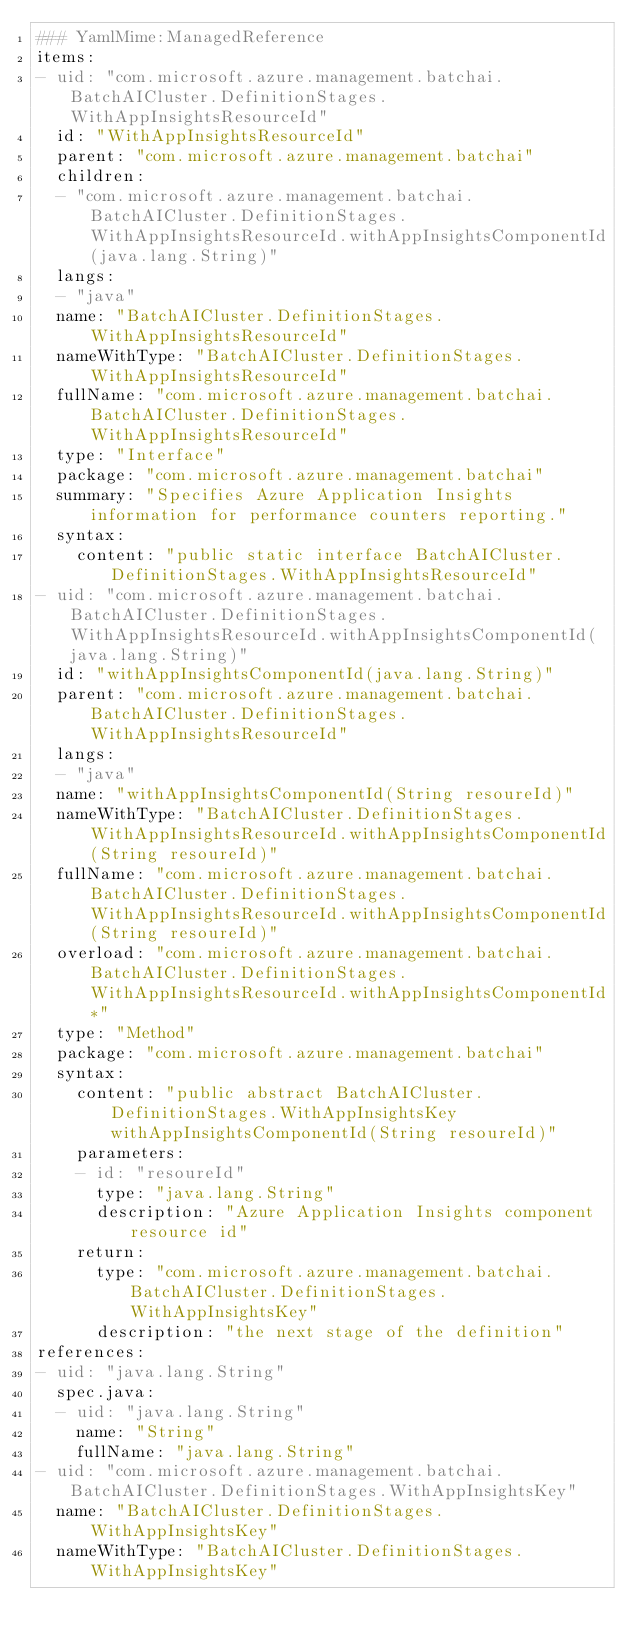<code> <loc_0><loc_0><loc_500><loc_500><_YAML_>### YamlMime:ManagedReference
items:
- uid: "com.microsoft.azure.management.batchai.BatchAICluster.DefinitionStages.WithAppInsightsResourceId"
  id: "WithAppInsightsResourceId"
  parent: "com.microsoft.azure.management.batchai"
  children:
  - "com.microsoft.azure.management.batchai.BatchAICluster.DefinitionStages.WithAppInsightsResourceId.withAppInsightsComponentId(java.lang.String)"
  langs:
  - "java"
  name: "BatchAICluster.DefinitionStages.WithAppInsightsResourceId"
  nameWithType: "BatchAICluster.DefinitionStages.WithAppInsightsResourceId"
  fullName: "com.microsoft.azure.management.batchai.BatchAICluster.DefinitionStages.WithAppInsightsResourceId"
  type: "Interface"
  package: "com.microsoft.azure.management.batchai"
  summary: "Specifies Azure Application Insights information for performance counters reporting."
  syntax:
    content: "public static interface BatchAICluster.DefinitionStages.WithAppInsightsResourceId"
- uid: "com.microsoft.azure.management.batchai.BatchAICluster.DefinitionStages.WithAppInsightsResourceId.withAppInsightsComponentId(java.lang.String)"
  id: "withAppInsightsComponentId(java.lang.String)"
  parent: "com.microsoft.azure.management.batchai.BatchAICluster.DefinitionStages.WithAppInsightsResourceId"
  langs:
  - "java"
  name: "withAppInsightsComponentId(String resoureId)"
  nameWithType: "BatchAICluster.DefinitionStages.WithAppInsightsResourceId.withAppInsightsComponentId(String resoureId)"
  fullName: "com.microsoft.azure.management.batchai.BatchAICluster.DefinitionStages.WithAppInsightsResourceId.withAppInsightsComponentId(String resoureId)"
  overload: "com.microsoft.azure.management.batchai.BatchAICluster.DefinitionStages.WithAppInsightsResourceId.withAppInsightsComponentId*"
  type: "Method"
  package: "com.microsoft.azure.management.batchai"
  syntax:
    content: "public abstract BatchAICluster.DefinitionStages.WithAppInsightsKey withAppInsightsComponentId(String resoureId)"
    parameters:
    - id: "resoureId"
      type: "java.lang.String"
      description: "Azure Application Insights component resource id"
    return:
      type: "com.microsoft.azure.management.batchai.BatchAICluster.DefinitionStages.WithAppInsightsKey"
      description: "the next stage of the definition"
references:
- uid: "java.lang.String"
  spec.java:
  - uid: "java.lang.String"
    name: "String"
    fullName: "java.lang.String"
- uid: "com.microsoft.azure.management.batchai.BatchAICluster.DefinitionStages.WithAppInsightsKey"
  name: "BatchAICluster.DefinitionStages.WithAppInsightsKey"
  nameWithType: "BatchAICluster.DefinitionStages.WithAppInsightsKey"</code> 